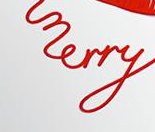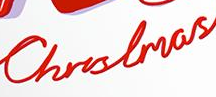Identify the words shown in these images in order, separated by a semicolon. merry; Christmas 